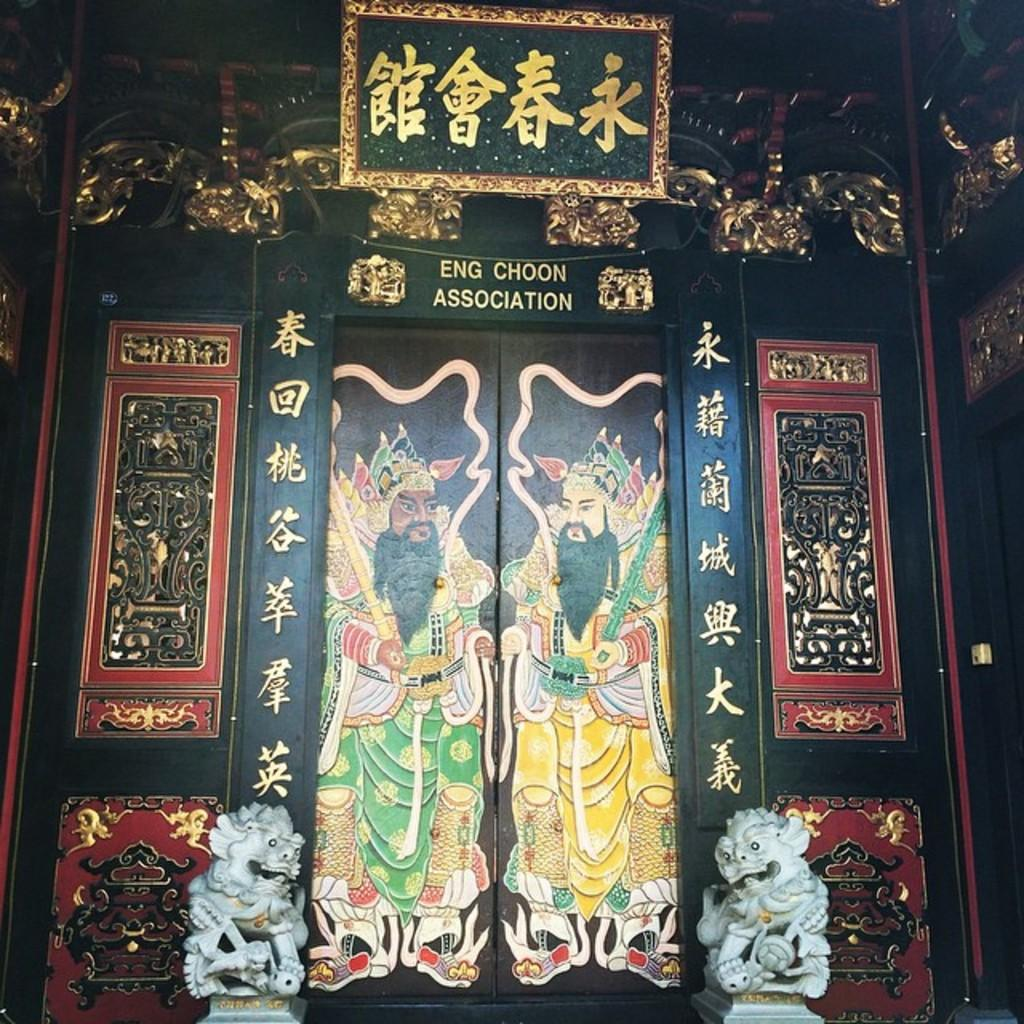What is depicted on the door in the image? There is a door with a painting in the image. What language is written on the painting? The painting has Chinese language on it. What is placed on top of the door? There is a photo frame on the top of the door. What type of statues are present at the front bottom side of the door? There are two small tiger statues at the front bottom side of the door. What activity is the airplane performing in the image? There is no airplane present in the image. What type of uniform is the fireman wearing in the image? There is no fireman present in the image. 